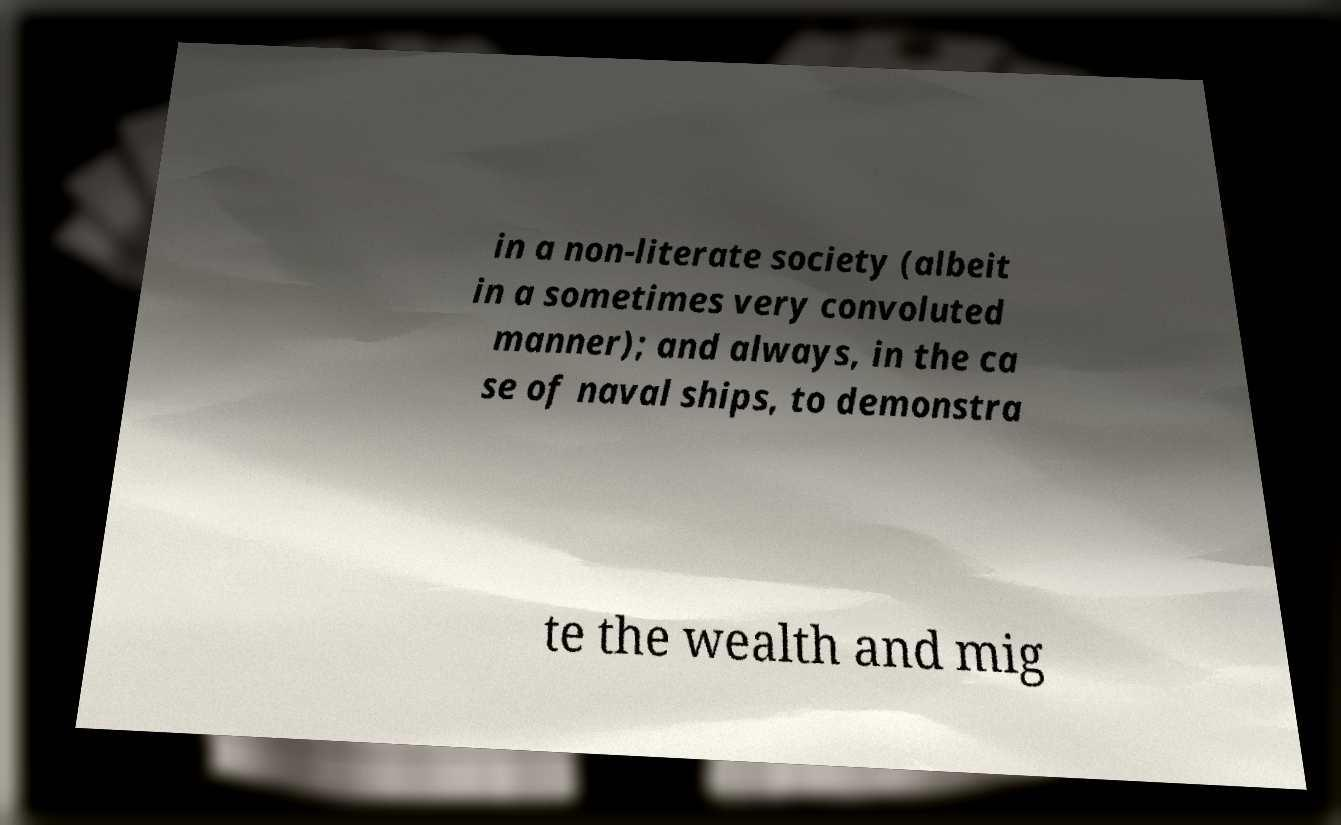Please identify and transcribe the text found in this image. in a non-literate society (albeit in a sometimes very convoluted manner); and always, in the ca se of naval ships, to demonstra te the wealth and mig 